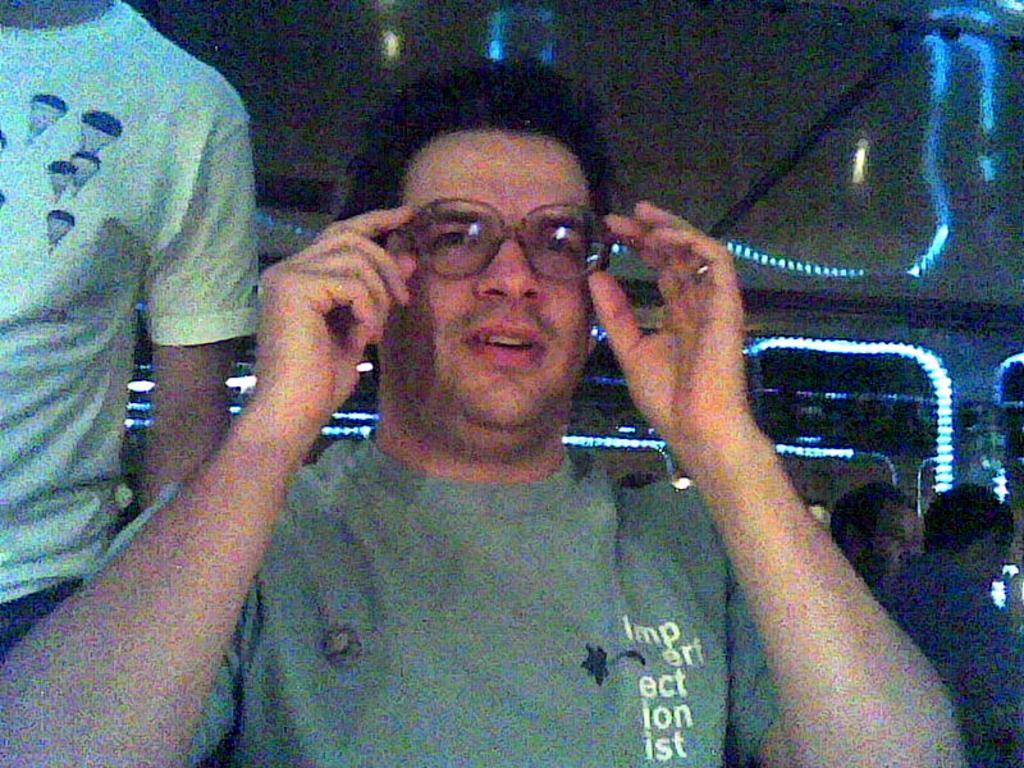In one or two sentences, can you explain what this image depicts? In this image in the front there is a person smiling. On the left side there is a man standing. On the right side there are persons. In the background there are lights. 